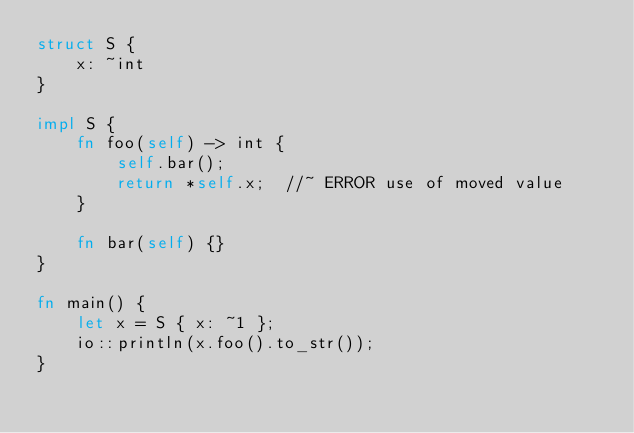Convert code to text. <code><loc_0><loc_0><loc_500><loc_500><_Rust_>struct S {
    x: ~int
}

impl S {
    fn foo(self) -> int {
        self.bar();
        return *self.x;  //~ ERROR use of moved value
    }

    fn bar(self) {}
}

fn main() {
    let x = S { x: ~1 };
    io::println(x.foo().to_str());
}

</code> 